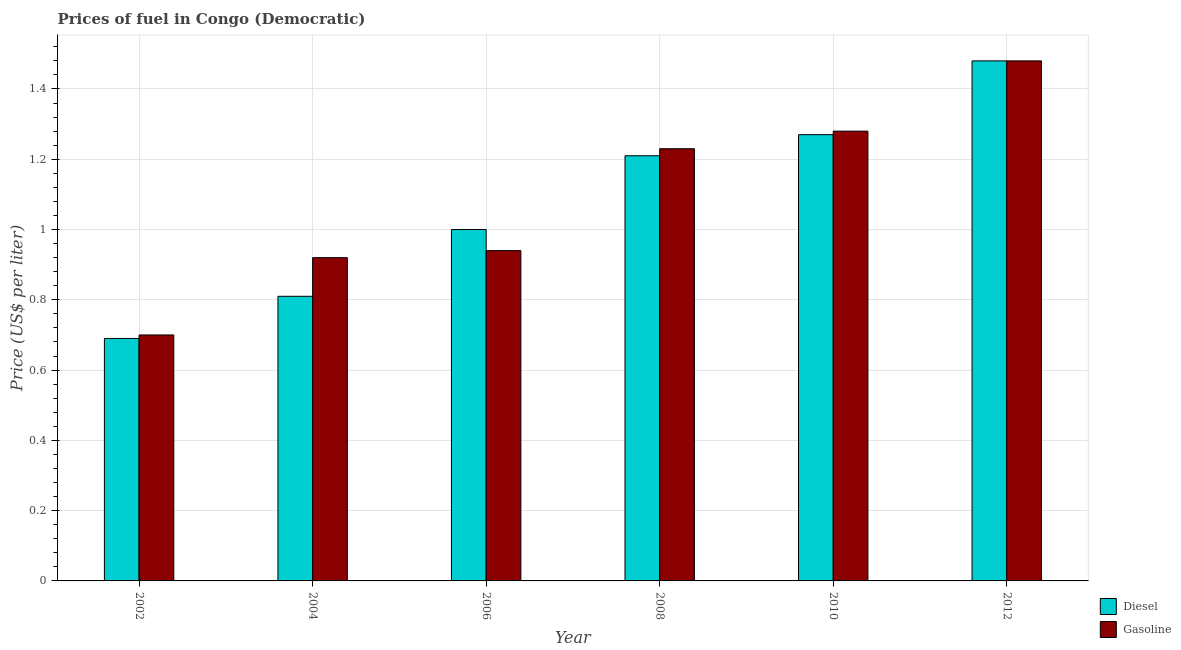Are the number of bars per tick equal to the number of legend labels?
Give a very brief answer. Yes. Are the number of bars on each tick of the X-axis equal?
Offer a terse response. Yes. How many bars are there on the 4th tick from the right?
Offer a very short reply. 2. In how many cases, is the number of bars for a given year not equal to the number of legend labels?
Provide a succinct answer. 0. What is the diesel price in 2012?
Give a very brief answer. 1.48. Across all years, what is the maximum diesel price?
Offer a very short reply. 1.48. In which year was the gasoline price maximum?
Your answer should be very brief. 2012. What is the total diesel price in the graph?
Ensure brevity in your answer.  6.46. What is the difference between the diesel price in 2008 and that in 2012?
Give a very brief answer. -0.27. What is the difference between the diesel price in 2008 and the gasoline price in 2010?
Offer a very short reply. -0.06. What is the average diesel price per year?
Your response must be concise. 1.08. In the year 2002, what is the difference between the diesel price and gasoline price?
Your answer should be compact. 0. What is the ratio of the gasoline price in 2004 to that in 2010?
Your answer should be compact. 0.72. Is the diesel price in 2002 less than that in 2010?
Provide a succinct answer. Yes. What is the difference between the highest and the second highest diesel price?
Provide a short and direct response. 0.21. What is the difference between the highest and the lowest diesel price?
Your answer should be compact. 0.79. In how many years, is the diesel price greater than the average diesel price taken over all years?
Make the answer very short. 3. Is the sum of the gasoline price in 2002 and 2004 greater than the maximum diesel price across all years?
Ensure brevity in your answer.  Yes. What does the 1st bar from the left in 2002 represents?
Your answer should be very brief. Diesel. What does the 2nd bar from the right in 2012 represents?
Offer a terse response. Diesel. How many years are there in the graph?
Your answer should be very brief. 6. What is the difference between two consecutive major ticks on the Y-axis?
Provide a succinct answer. 0.2. Are the values on the major ticks of Y-axis written in scientific E-notation?
Ensure brevity in your answer.  No. Where does the legend appear in the graph?
Your answer should be compact. Bottom right. How are the legend labels stacked?
Provide a short and direct response. Vertical. What is the title of the graph?
Make the answer very short. Prices of fuel in Congo (Democratic). What is the label or title of the Y-axis?
Your answer should be compact. Price (US$ per liter). What is the Price (US$ per liter) of Diesel in 2002?
Provide a short and direct response. 0.69. What is the Price (US$ per liter) in Gasoline in 2002?
Offer a terse response. 0.7. What is the Price (US$ per liter) of Diesel in 2004?
Offer a very short reply. 0.81. What is the Price (US$ per liter) in Gasoline in 2004?
Provide a succinct answer. 0.92. What is the Price (US$ per liter) of Gasoline in 2006?
Offer a terse response. 0.94. What is the Price (US$ per liter) of Diesel in 2008?
Provide a short and direct response. 1.21. What is the Price (US$ per liter) in Gasoline in 2008?
Provide a short and direct response. 1.23. What is the Price (US$ per liter) in Diesel in 2010?
Your answer should be very brief. 1.27. What is the Price (US$ per liter) of Gasoline in 2010?
Keep it short and to the point. 1.28. What is the Price (US$ per liter) in Diesel in 2012?
Your answer should be compact. 1.48. What is the Price (US$ per liter) in Gasoline in 2012?
Offer a terse response. 1.48. Across all years, what is the maximum Price (US$ per liter) in Diesel?
Make the answer very short. 1.48. Across all years, what is the maximum Price (US$ per liter) in Gasoline?
Provide a succinct answer. 1.48. Across all years, what is the minimum Price (US$ per liter) of Diesel?
Provide a short and direct response. 0.69. Across all years, what is the minimum Price (US$ per liter) in Gasoline?
Offer a terse response. 0.7. What is the total Price (US$ per liter) in Diesel in the graph?
Offer a very short reply. 6.46. What is the total Price (US$ per liter) in Gasoline in the graph?
Provide a succinct answer. 6.55. What is the difference between the Price (US$ per liter) in Diesel in 2002 and that in 2004?
Provide a short and direct response. -0.12. What is the difference between the Price (US$ per liter) in Gasoline in 2002 and that in 2004?
Keep it short and to the point. -0.22. What is the difference between the Price (US$ per liter) of Diesel in 2002 and that in 2006?
Keep it short and to the point. -0.31. What is the difference between the Price (US$ per liter) of Gasoline in 2002 and that in 2006?
Give a very brief answer. -0.24. What is the difference between the Price (US$ per liter) in Diesel in 2002 and that in 2008?
Make the answer very short. -0.52. What is the difference between the Price (US$ per liter) in Gasoline in 2002 and that in 2008?
Your response must be concise. -0.53. What is the difference between the Price (US$ per liter) in Diesel in 2002 and that in 2010?
Your answer should be very brief. -0.58. What is the difference between the Price (US$ per liter) of Gasoline in 2002 and that in 2010?
Your answer should be compact. -0.58. What is the difference between the Price (US$ per liter) in Diesel in 2002 and that in 2012?
Make the answer very short. -0.79. What is the difference between the Price (US$ per liter) in Gasoline in 2002 and that in 2012?
Offer a terse response. -0.78. What is the difference between the Price (US$ per liter) of Diesel in 2004 and that in 2006?
Your answer should be very brief. -0.19. What is the difference between the Price (US$ per liter) in Gasoline in 2004 and that in 2006?
Keep it short and to the point. -0.02. What is the difference between the Price (US$ per liter) of Diesel in 2004 and that in 2008?
Keep it short and to the point. -0.4. What is the difference between the Price (US$ per liter) of Gasoline in 2004 and that in 2008?
Your answer should be compact. -0.31. What is the difference between the Price (US$ per liter) of Diesel in 2004 and that in 2010?
Give a very brief answer. -0.46. What is the difference between the Price (US$ per liter) in Gasoline in 2004 and that in 2010?
Your answer should be compact. -0.36. What is the difference between the Price (US$ per liter) in Diesel in 2004 and that in 2012?
Offer a very short reply. -0.67. What is the difference between the Price (US$ per liter) of Gasoline in 2004 and that in 2012?
Ensure brevity in your answer.  -0.56. What is the difference between the Price (US$ per liter) of Diesel in 2006 and that in 2008?
Offer a very short reply. -0.21. What is the difference between the Price (US$ per liter) in Gasoline in 2006 and that in 2008?
Your answer should be compact. -0.29. What is the difference between the Price (US$ per liter) in Diesel in 2006 and that in 2010?
Provide a short and direct response. -0.27. What is the difference between the Price (US$ per liter) in Gasoline in 2006 and that in 2010?
Provide a succinct answer. -0.34. What is the difference between the Price (US$ per liter) of Diesel in 2006 and that in 2012?
Offer a very short reply. -0.48. What is the difference between the Price (US$ per liter) of Gasoline in 2006 and that in 2012?
Your answer should be compact. -0.54. What is the difference between the Price (US$ per liter) in Diesel in 2008 and that in 2010?
Ensure brevity in your answer.  -0.06. What is the difference between the Price (US$ per liter) in Diesel in 2008 and that in 2012?
Make the answer very short. -0.27. What is the difference between the Price (US$ per liter) in Gasoline in 2008 and that in 2012?
Ensure brevity in your answer.  -0.25. What is the difference between the Price (US$ per liter) of Diesel in 2010 and that in 2012?
Your answer should be compact. -0.21. What is the difference between the Price (US$ per liter) in Diesel in 2002 and the Price (US$ per liter) in Gasoline in 2004?
Offer a terse response. -0.23. What is the difference between the Price (US$ per liter) of Diesel in 2002 and the Price (US$ per liter) of Gasoline in 2008?
Offer a very short reply. -0.54. What is the difference between the Price (US$ per liter) of Diesel in 2002 and the Price (US$ per liter) of Gasoline in 2010?
Ensure brevity in your answer.  -0.59. What is the difference between the Price (US$ per liter) in Diesel in 2002 and the Price (US$ per liter) in Gasoline in 2012?
Ensure brevity in your answer.  -0.79. What is the difference between the Price (US$ per liter) of Diesel in 2004 and the Price (US$ per liter) of Gasoline in 2006?
Offer a terse response. -0.13. What is the difference between the Price (US$ per liter) of Diesel in 2004 and the Price (US$ per liter) of Gasoline in 2008?
Provide a short and direct response. -0.42. What is the difference between the Price (US$ per liter) of Diesel in 2004 and the Price (US$ per liter) of Gasoline in 2010?
Make the answer very short. -0.47. What is the difference between the Price (US$ per liter) of Diesel in 2004 and the Price (US$ per liter) of Gasoline in 2012?
Keep it short and to the point. -0.67. What is the difference between the Price (US$ per liter) in Diesel in 2006 and the Price (US$ per liter) in Gasoline in 2008?
Your answer should be compact. -0.23. What is the difference between the Price (US$ per liter) of Diesel in 2006 and the Price (US$ per liter) of Gasoline in 2010?
Offer a terse response. -0.28. What is the difference between the Price (US$ per liter) in Diesel in 2006 and the Price (US$ per liter) in Gasoline in 2012?
Offer a terse response. -0.48. What is the difference between the Price (US$ per liter) in Diesel in 2008 and the Price (US$ per liter) in Gasoline in 2010?
Make the answer very short. -0.07. What is the difference between the Price (US$ per liter) in Diesel in 2008 and the Price (US$ per liter) in Gasoline in 2012?
Your answer should be very brief. -0.27. What is the difference between the Price (US$ per liter) of Diesel in 2010 and the Price (US$ per liter) of Gasoline in 2012?
Your answer should be very brief. -0.21. What is the average Price (US$ per liter) in Diesel per year?
Keep it short and to the point. 1.08. What is the average Price (US$ per liter) of Gasoline per year?
Give a very brief answer. 1.09. In the year 2002, what is the difference between the Price (US$ per liter) of Diesel and Price (US$ per liter) of Gasoline?
Your response must be concise. -0.01. In the year 2004, what is the difference between the Price (US$ per liter) in Diesel and Price (US$ per liter) in Gasoline?
Provide a succinct answer. -0.11. In the year 2006, what is the difference between the Price (US$ per liter) in Diesel and Price (US$ per liter) in Gasoline?
Provide a succinct answer. 0.06. In the year 2008, what is the difference between the Price (US$ per liter) of Diesel and Price (US$ per liter) of Gasoline?
Your answer should be compact. -0.02. In the year 2010, what is the difference between the Price (US$ per liter) of Diesel and Price (US$ per liter) of Gasoline?
Provide a short and direct response. -0.01. What is the ratio of the Price (US$ per liter) in Diesel in 2002 to that in 2004?
Give a very brief answer. 0.85. What is the ratio of the Price (US$ per liter) of Gasoline in 2002 to that in 2004?
Give a very brief answer. 0.76. What is the ratio of the Price (US$ per liter) of Diesel in 2002 to that in 2006?
Ensure brevity in your answer.  0.69. What is the ratio of the Price (US$ per liter) of Gasoline in 2002 to that in 2006?
Offer a very short reply. 0.74. What is the ratio of the Price (US$ per liter) of Diesel in 2002 to that in 2008?
Offer a very short reply. 0.57. What is the ratio of the Price (US$ per liter) in Gasoline in 2002 to that in 2008?
Offer a very short reply. 0.57. What is the ratio of the Price (US$ per liter) in Diesel in 2002 to that in 2010?
Your answer should be very brief. 0.54. What is the ratio of the Price (US$ per liter) in Gasoline in 2002 to that in 2010?
Give a very brief answer. 0.55. What is the ratio of the Price (US$ per liter) of Diesel in 2002 to that in 2012?
Provide a succinct answer. 0.47. What is the ratio of the Price (US$ per liter) in Gasoline in 2002 to that in 2012?
Your answer should be very brief. 0.47. What is the ratio of the Price (US$ per liter) of Diesel in 2004 to that in 2006?
Make the answer very short. 0.81. What is the ratio of the Price (US$ per liter) in Gasoline in 2004 to that in 2006?
Provide a short and direct response. 0.98. What is the ratio of the Price (US$ per liter) in Diesel in 2004 to that in 2008?
Provide a succinct answer. 0.67. What is the ratio of the Price (US$ per liter) of Gasoline in 2004 to that in 2008?
Your answer should be compact. 0.75. What is the ratio of the Price (US$ per liter) of Diesel in 2004 to that in 2010?
Offer a terse response. 0.64. What is the ratio of the Price (US$ per liter) in Gasoline in 2004 to that in 2010?
Your response must be concise. 0.72. What is the ratio of the Price (US$ per liter) in Diesel in 2004 to that in 2012?
Make the answer very short. 0.55. What is the ratio of the Price (US$ per liter) of Gasoline in 2004 to that in 2012?
Provide a succinct answer. 0.62. What is the ratio of the Price (US$ per liter) in Diesel in 2006 to that in 2008?
Your answer should be very brief. 0.83. What is the ratio of the Price (US$ per liter) in Gasoline in 2006 to that in 2008?
Provide a succinct answer. 0.76. What is the ratio of the Price (US$ per liter) of Diesel in 2006 to that in 2010?
Offer a terse response. 0.79. What is the ratio of the Price (US$ per liter) of Gasoline in 2006 to that in 2010?
Make the answer very short. 0.73. What is the ratio of the Price (US$ per liter) of Diesel in 2006 to that in 2012?
Provide a succinct answer. 0.68. What is the ratio of the Price (US$ per liter) of Gasoline in 2006 to that in 2012?
Keep it short and to the point. 0.64. What is the ratio of the Price (US$ per liter) in Diesel in 2008 to that in 2010?
Your response must be concise. 0.95. What is the ratio of the Price (US$ per liter) of Gasoline in 2008 to that in 2010?
Make the answer very short. 0.96. What is the ratio of the Price (US$ per liter) in Diesel in 2008 to that in 2012?
Give a very brief answer. 0.82. What is the ratio of the Price (US$ per liter) of Gasoline in 2008 to that in 2012?
Give a very brief answer. 0.83. What is the ratio of the Price (US$ per liter) in Diesel in 2010 to that in 2012?
Your answer should be very brief. 0.86. What is the ratio of the Price (US$ per liter) of Gasoline in 2010 to that in 2012?
Offer a terse response. 0.86. What is the difference between the highest and the second highest Price (US$ per liter) of Diesel?
Your response must be concise. 0.21. What is the difference between the highest and the second highest Price (US$ per liter) in Gasoline?
Provide a succinct answer. 0.2. What is the difference between the highest and the lowest Price (US$ per liter) in Diesel?
Your response must be concise. 0.79. What is the difference between the highest and the lowest Price (US$ per liter) of Gasoline?
Provide a succinct answer. 0.78. 